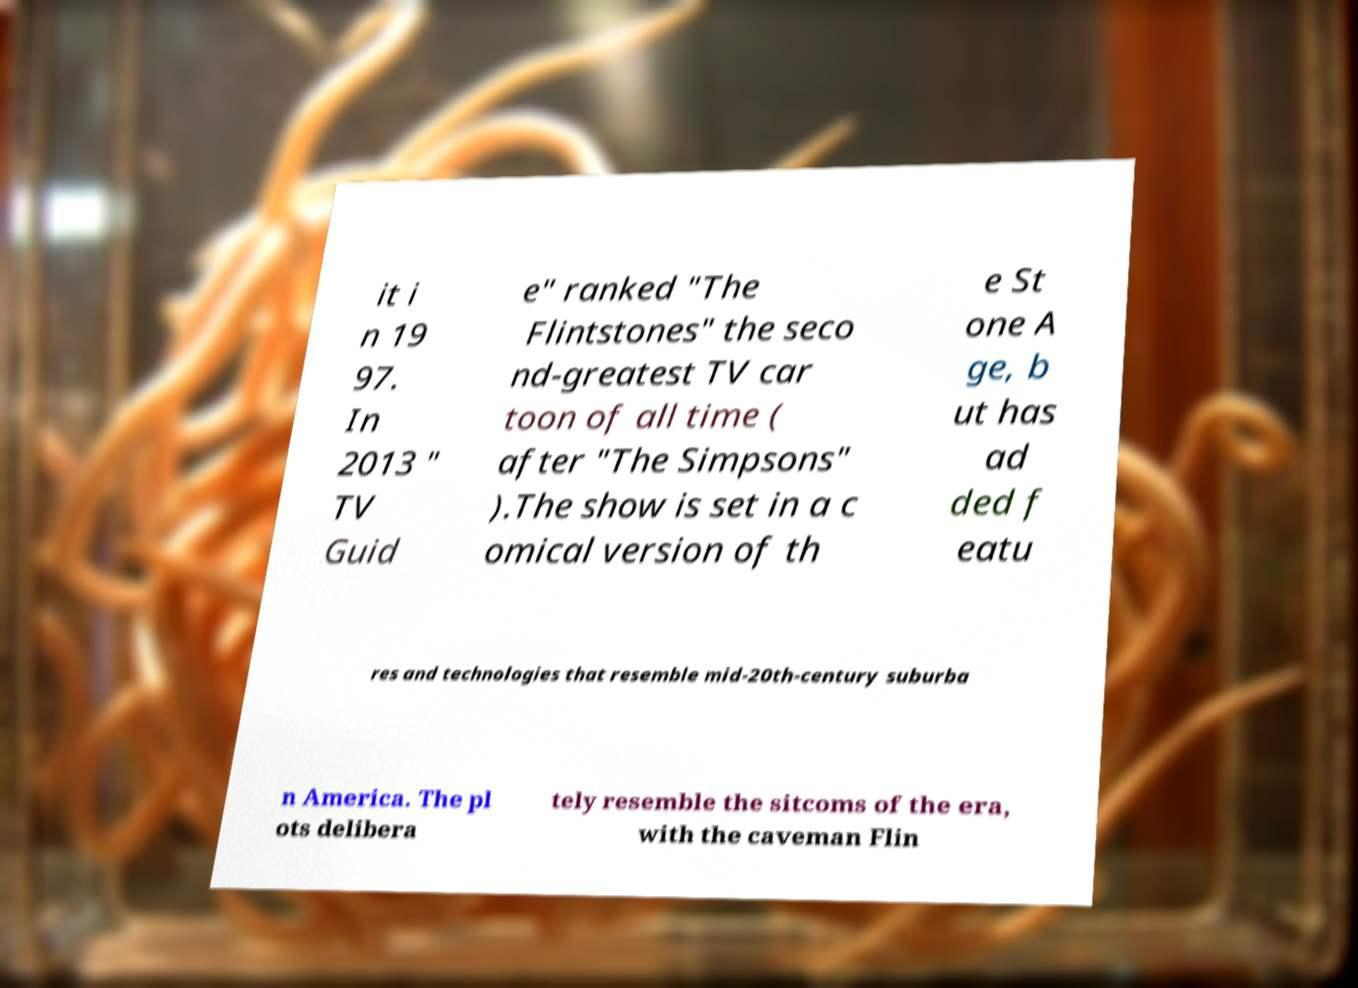Can you read and provide the text displayed in the image?This photo seems to have some interesting text. Can you extract and type it out for me? it i n 19 97. In 2013 " TV Guid e" ranked "The Flintstones" the seco nd-greatest TV car toon of all time ( after "The Simpsons" ).The show is set in a c omical version of th e St one A ge, b ut has ad ded f eatu res and technologies that resemble mid-20th-century suburba n America. The pl ots delibera tely resemble the sitcoms of the era, with the caveman Flin 